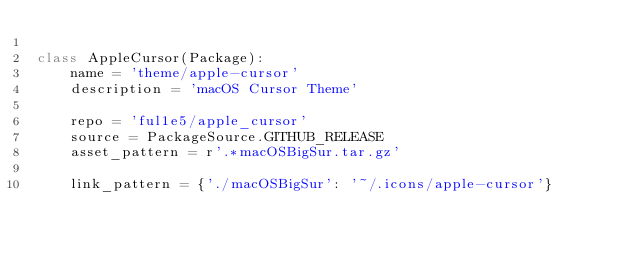<code> <loc_0><loc_0><loc_500><loc_500><_Python_>
class AppleCursor(Package):
    name = 'theme/apple-cursor'
    description = 'macOS Cursor Theme'

    repo = 'ful1e5/apple_cursor'
    source = PackageSource.GITHUB_RELEASE
    asset_pattern = r'.*macOSBigSur.tar.gz'

    link_pattern = {'./macOSBigSur': '~/.icons/apple-cursor'}
</code> 